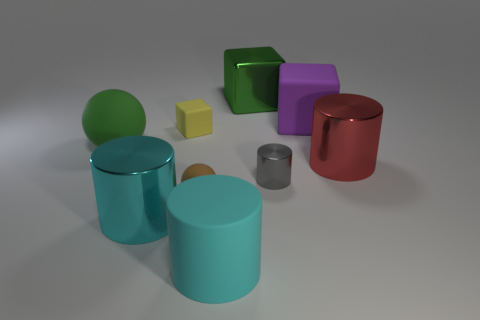How many cyan metal cylinders are on the left side of the tiny rubber thing that is behind the large red metallic thing that is in front of the large green metal thing? There is one cyan metal cylinder located to the left of the tiny rubber object. This tiny rubber object is positioned behind the large red metallic object, which in turn is situated in front of the large green metal object. 